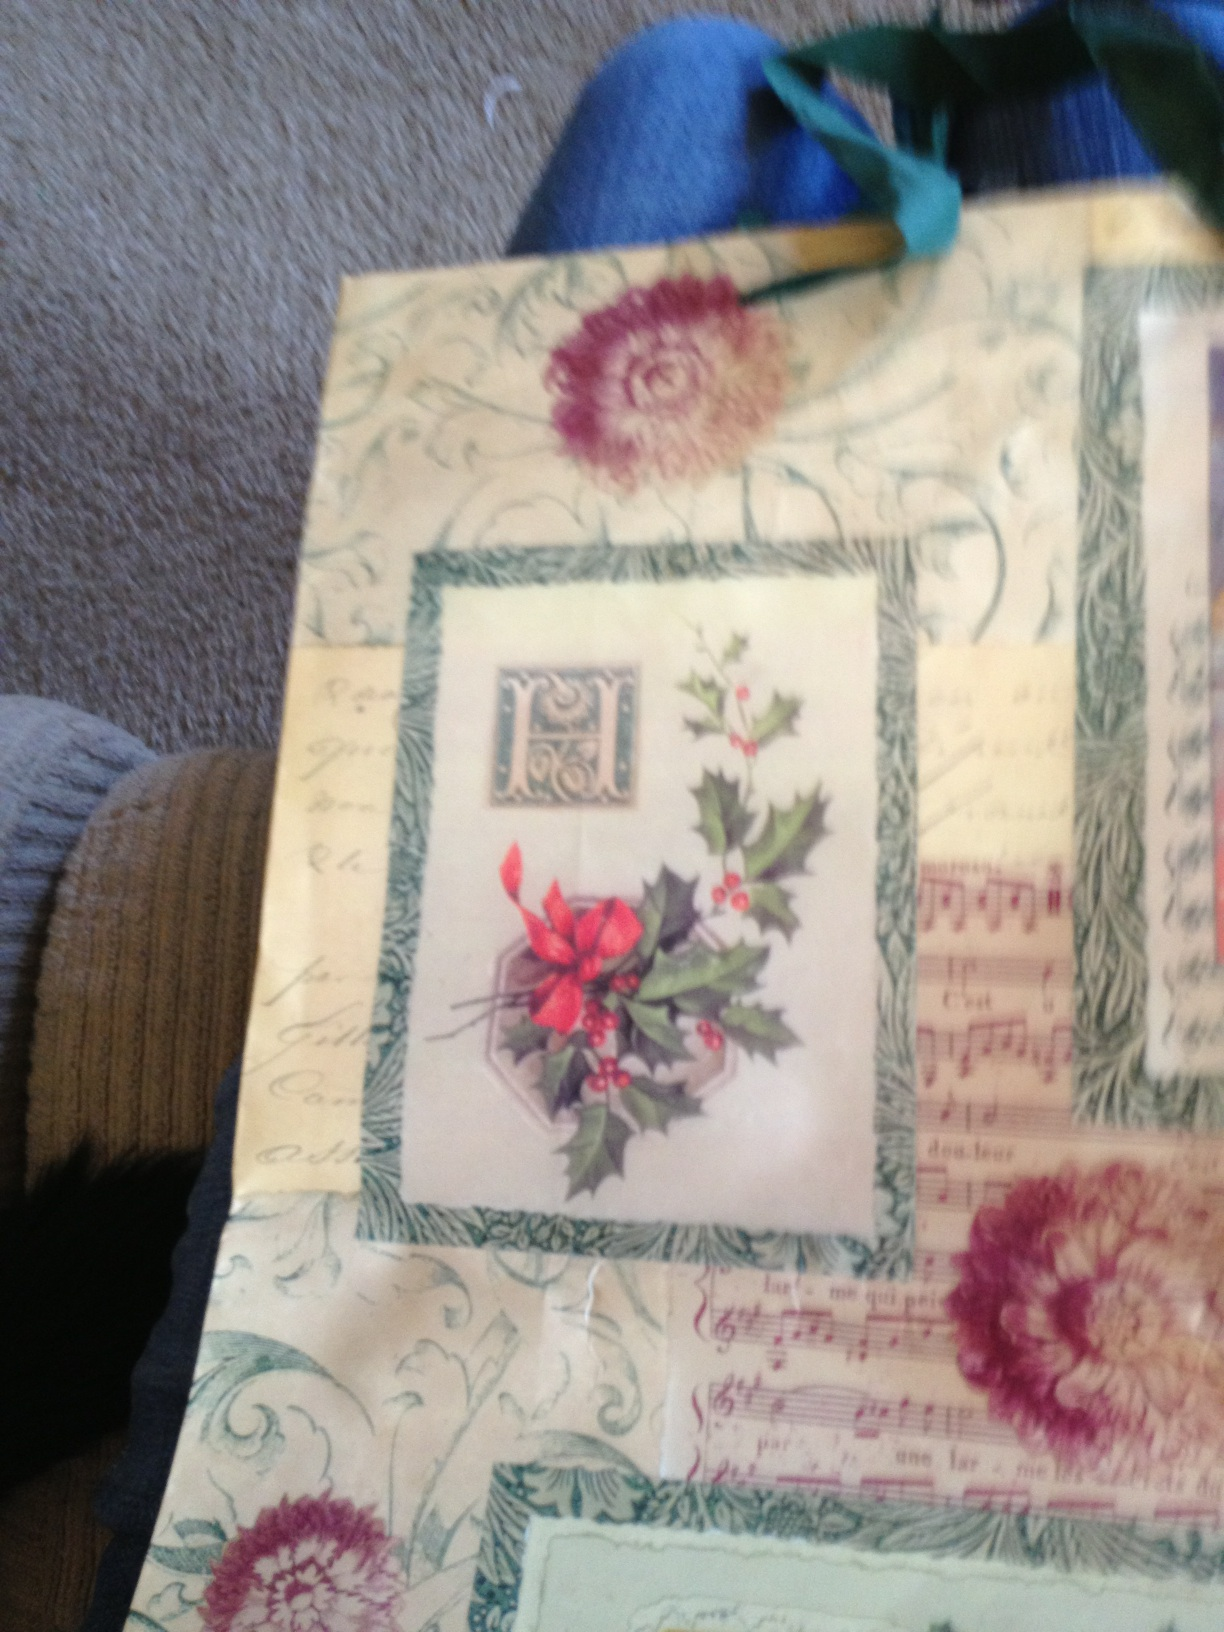If this design on the gift bag could come to life, what might it do? Imagine the holly leaves magically glowing and performing a holiday dance, while the sheet music drifts up and around in the air playing a melodious Christmas tune. The intricate patterns could shimmer and unfold, creating an enchanting holiday spectacle right before your eyes. That sounds amazing! What else do you see? In this magical scene, each blossom bursts into a gentle snowfall of petals that flutter down like snowflakes. The archaic letter 'H' begins to glow warmly, guiding you to a cozy, festive gathering where friends and family celebrate joyfully. What kind of festive meal could be served at this magical gathering? The meal at this magical gathering would feature classic holiday dishes such as a golden-roasted turkey, honey-glazed ham, mashed potatoes with rich gravy, cranberry sauce, and warm, spiced cider. For dessert, there would be a selection of pies like pumpkin and apple, as well as freshly-baked cookies shaped in festive designs. If the bag had a secret message hidden in the design, what could it be? The secret message hidden within the design might be something heartfelt and timeless like, 'May your holidays be filled with warmth and cheer, embracing the spirit of love and giving.' An old-fashioned script could be meticulously hidden among the intricate patterns and sheet music, waiting for someone with a keen eye to uncover it. 